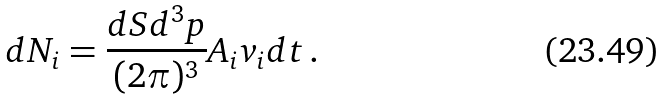<formula> <loc_0><loc_0><loc_500><loc_500>d N _ { i } = \frac { d S d ^ { 3 } p } { ( 2 \pi ) ^ { 3 } } A _ { i } v _ { i } d t \, .</formula> 